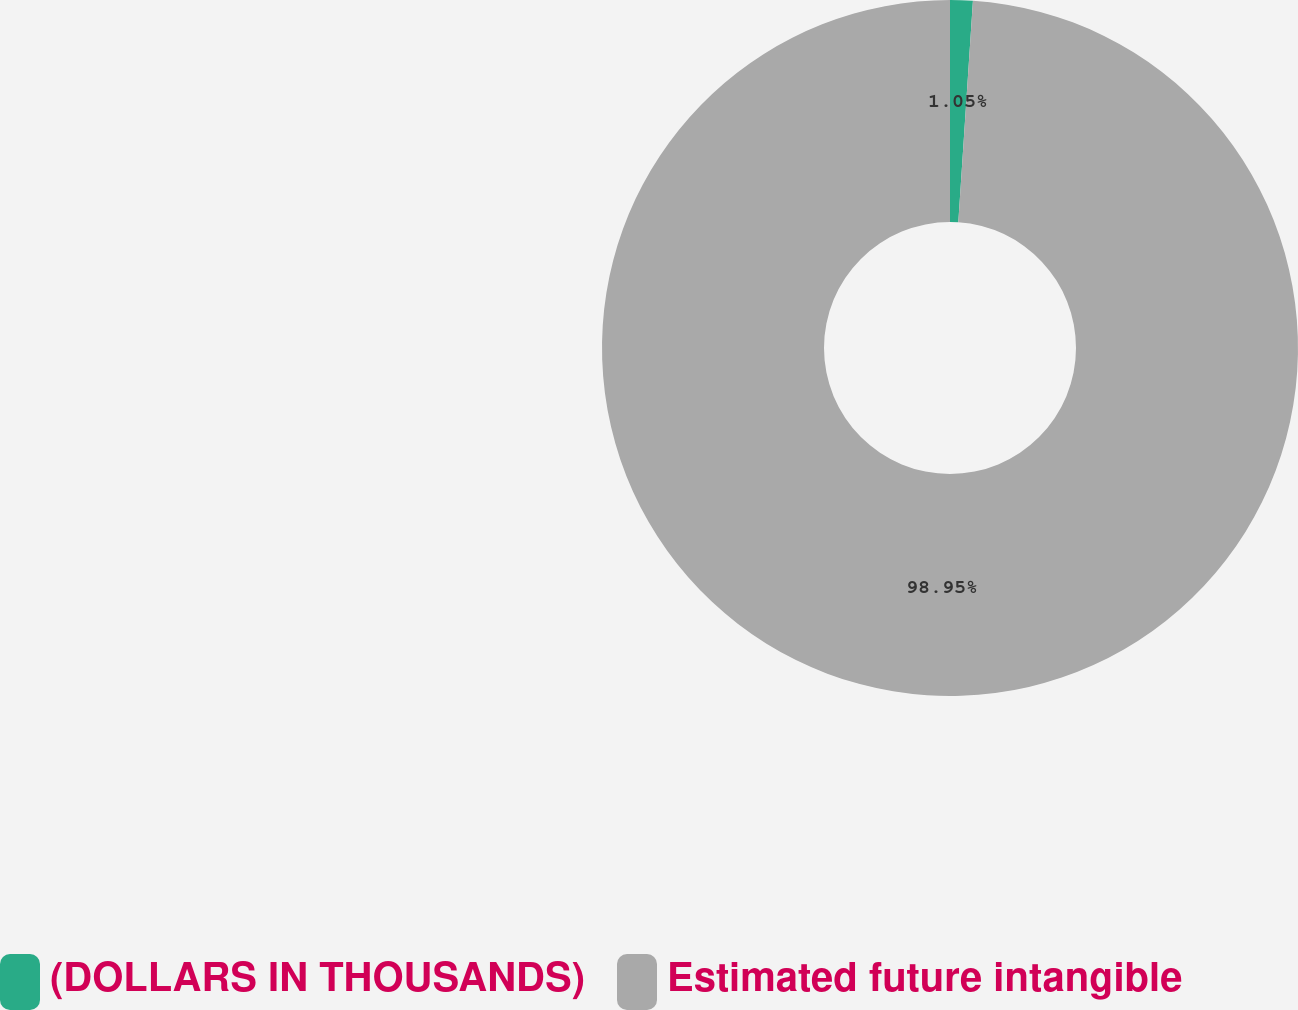Convert chart. <chart><loc_0><loc_0><loc_500><loc_500><pie_chart><fcel>(DOLLARS IN THOUSANDS)<fcel>Estimated future intangible<nl><fcel>1.05%<fcel>98.95%<nl></chart> 